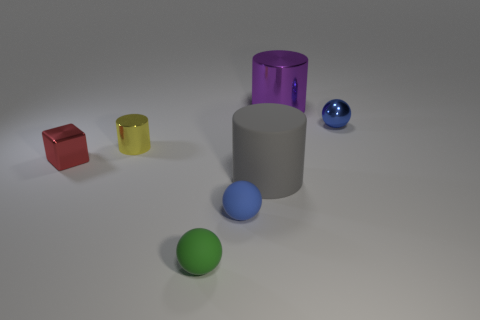Add 2 yellow metal things. How many objects exist? 9 Subtract all rubber balls. How many balls are left? 1 Subtract all blue spheres. How many spheres are left? 1 Subtract all cyan cylinders. How many blue spheres are left? 2 Subtract 1 cylinders. How many cylinders are left? 2 Subtract all spheres. How many objects are left? 4 Subtract all large yellow cubes. Subtract all large gray matte cylinders. How many objects are left? 6 Add 6 small shiny balls. How many small shiny balls are left? 7 Add 6 small red blocks. How many small red blocks exist? 7 Subtract 0 brown cylinders. How many objects are left? 7 